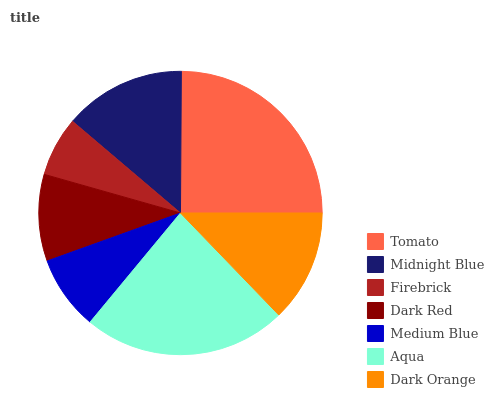Is Firebrick the minimum?
Answer yes or no. Yes. Is Tomato the maximum?
Answer yes or no. Yes. Is Midnight Blue the minimum?
Answer yes or no. No. Is Midnight Blue the maximum?
Answer yes or no. No. Is Tomato greater than Midnight Blue?
Answer yes or no. Yes. Is Midnight Blue less than Tomato?
Answer yes or no. Yes. Is Midnight Blue greater than Tomato?
Answer yes or no. No. Is Tomato less than Midnight Blue?
Answer yes or no. No. Is Dark Orange the high median?
Answer yes or no. Yes. Is Dark Orange the low median?
Answer yes or no. Yes. Is Aqua the high median?
Answer yes or no. No. Is Tomato the low median?
Answer yes or no. No. 